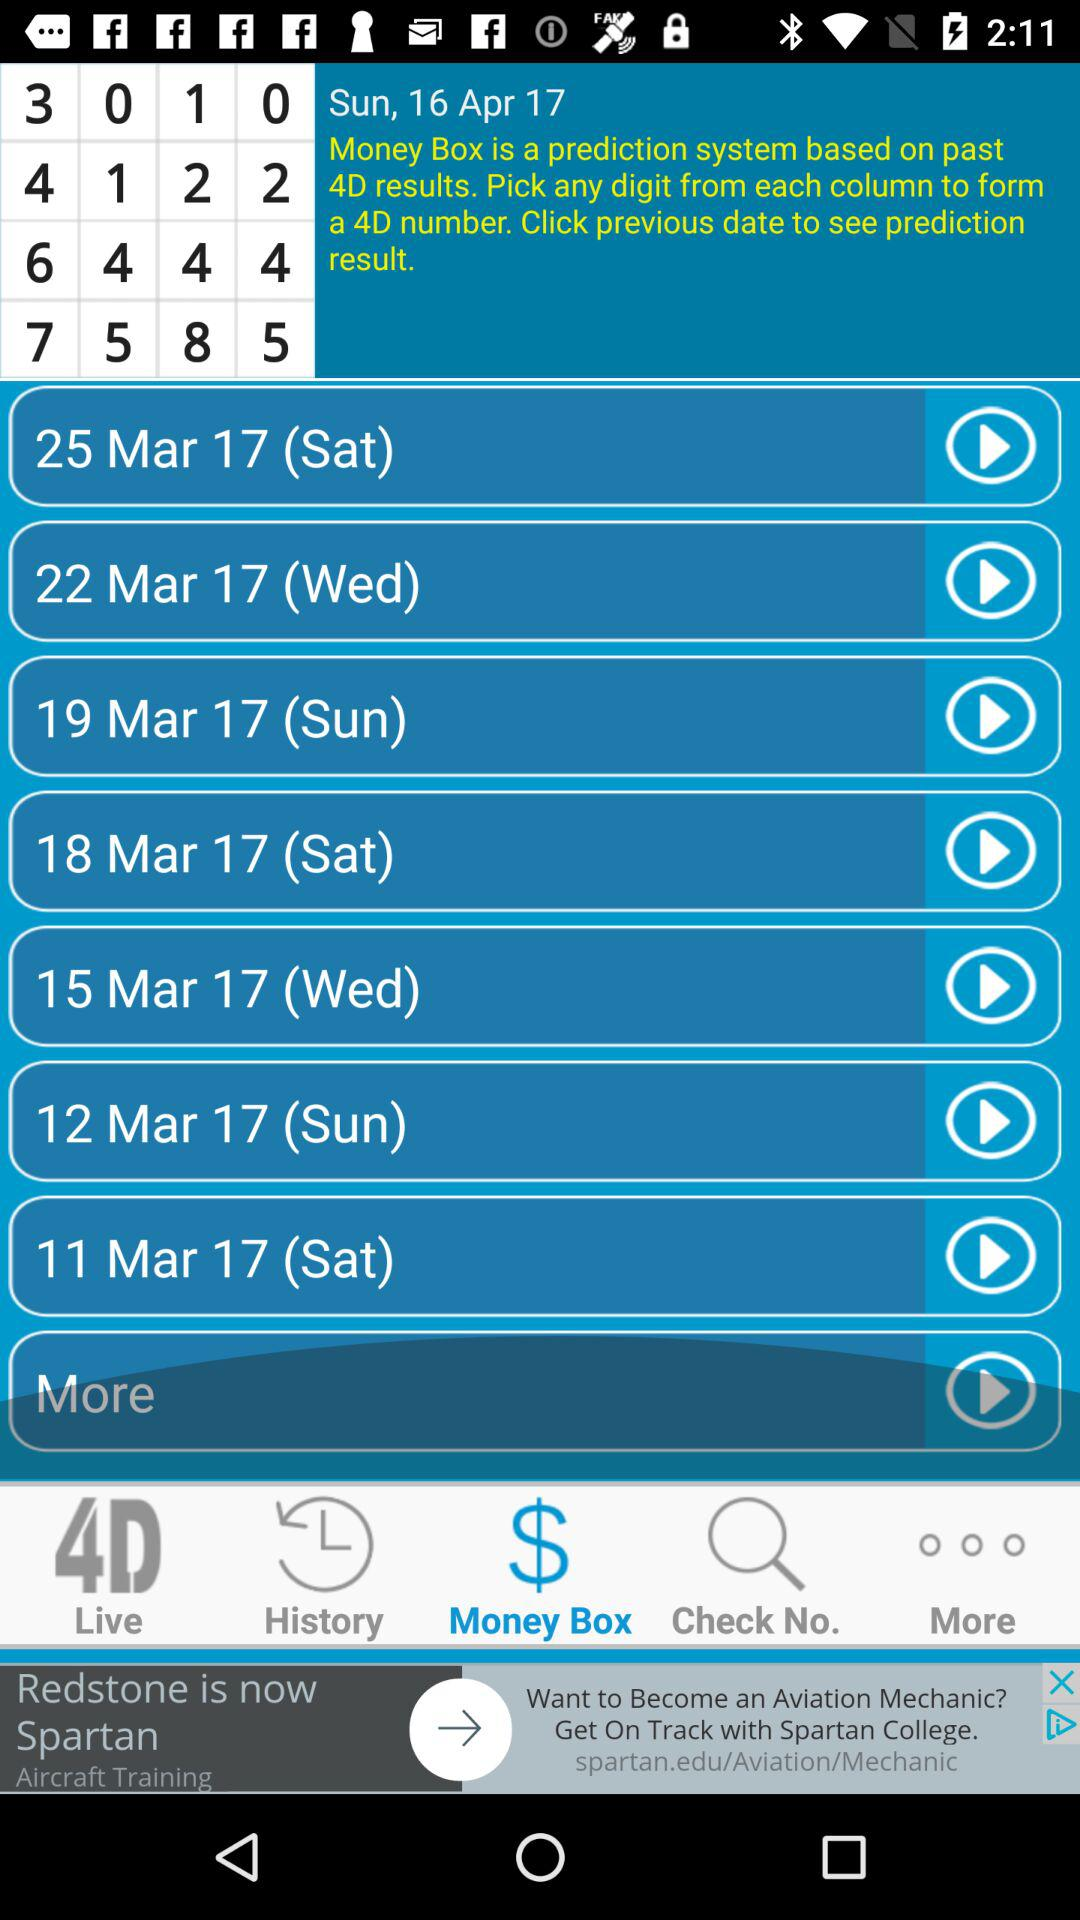What day is it on March 19, 2017? The day is Sunday. 